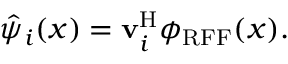<formula> <loc_0><loc_0><loc_500><loc_500>\hat { \psi } _ { i } ( x ) = v _ { i } ^ { H } \phi _ { R F F } ( x ) .</formula> 